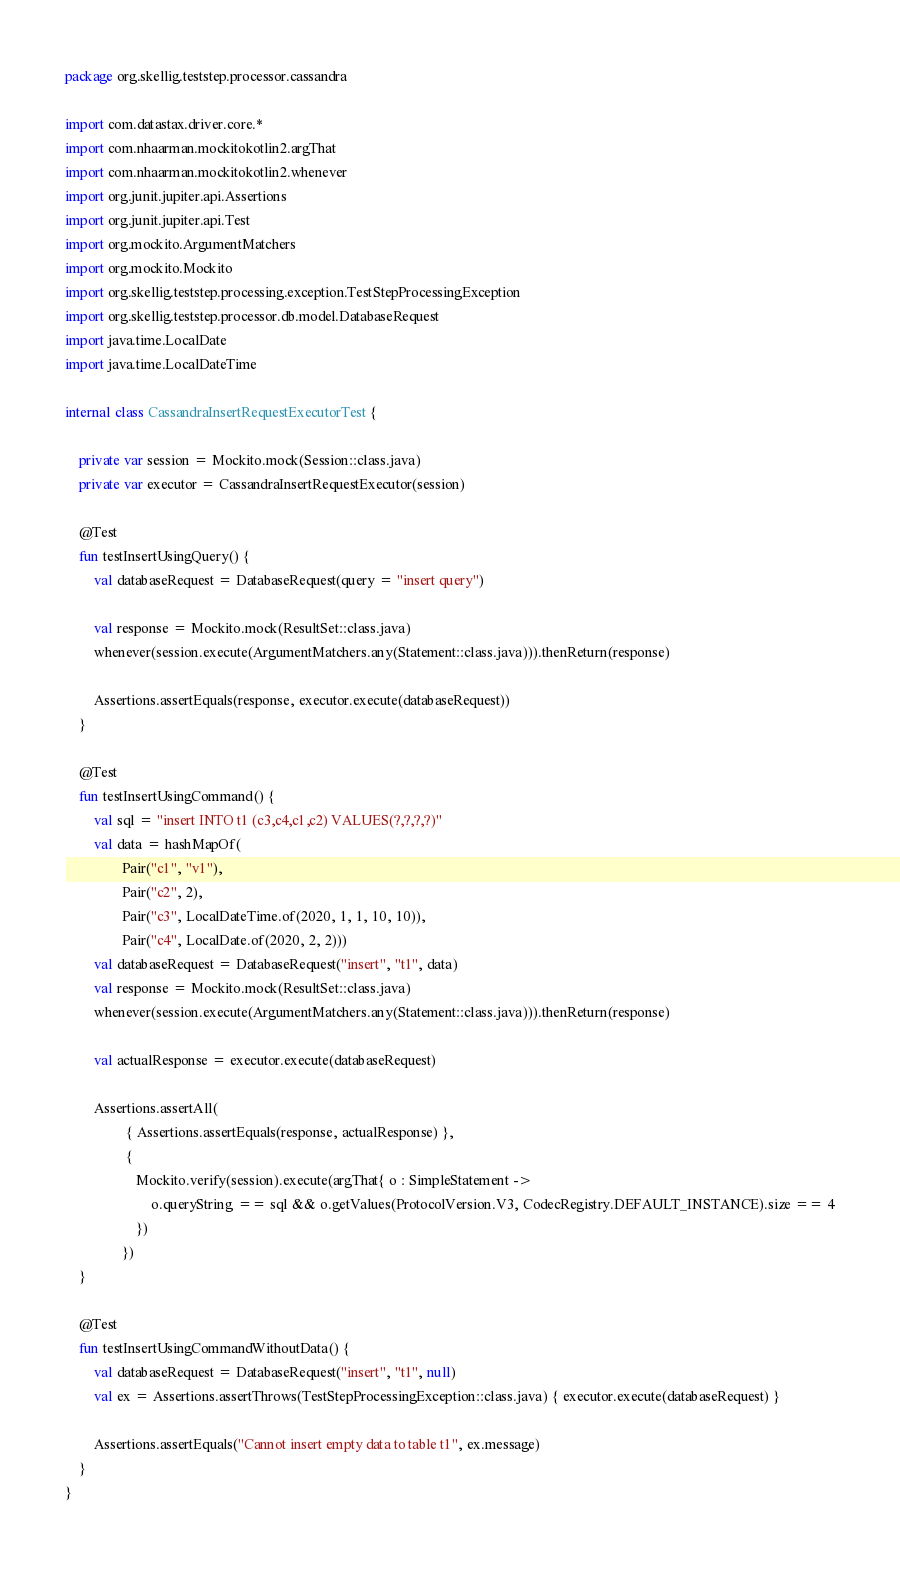<code> <loc_0><loc_0><loc_500><loc_500><_Kotlin_>package org.skellig.teststep.processor.cassandra

import com.datastax.driver.core.*
import com.nhaarman.mockitokotlin2.argThat
import com.nhaarman.mockitokotlin2.whenever
import org.junit.jupiter.api.Assertions
import org.junit.jupiter.api.Test
import org.mockito.ArgumentMatchers
import org.mockito.Mockito
import org.skellig.teststep.processing.exception.TestStepProcessingException
import org.skellig.teststep.processor.db.model.DatabaseRequest
import java.time.LocalDate
import java.time.LocalDateTime

internal class CassandraInsertRequestExecutorTest {

    private var session = Mockito.mock(Session::class.java)
    private var executor = CassandraInsertRequestExecutor(session)

    @Test
    fun testInsertUsingQuery() {
        val databaseRequest = DatabaseRequest(query = "insert query")

        val response = Mockito.mock(ResultSet::class.java)
        whenever(session.execute(ArgumentMatchers.any(Statement::class.java))).thenReturn(response)

        Assertions.assertEquals(response, executor.execute(databaseRequest))
    }

    @Test
    fun testInsertUsingCommand() {
        val sql = "insert INTO t1 (c3,c4,c1,c2) VALUES(?,?,?,?)"
        val data = hashMapOf(
                Pair("c1", "v1"),
                Pair("c2", 2),
                Pair("c3", LocalDateTime.of(2020, 1, 1, 10, 10)),
                Pair("c4", LocalDate.of(2020, 2, 2)))
        val databaseRequest = DatabaseRequest("insert", "t1", data)
        val response = Mockito.mock(ResultSet::class.java)
        whenever(session.execute(ArgumentMatchers.any(Statement::class.java))).thenReturn(response)

        val actualResponse = executor.execute(databaseRequest)

        Assertions.assertAll(
                 { Assertions.assertEquals(response, actualResponse) },
                 {
                    Mockito.verify(session).execute(argThat{ o : SimpleStatement ->
                        o.queryString == sql && o.getValues(ProtocolVersion.V3, CodecRegistry.DEFAULT_INSTANCE).size == 4
                    })
                })
    }

    @Test
    fun testInsertUsingCommandWithoutData() {
        val databaseRequest = DatabaseRequest("insert", "t1", null)
        val ex = Assertions.assertThrows(TestStepProcessingException::class.java) { executor.execute(databaseRequest) }

        Assertions.assertEquals("Cannot insert empty data to table t1", ex.message)
    }
}</code> 